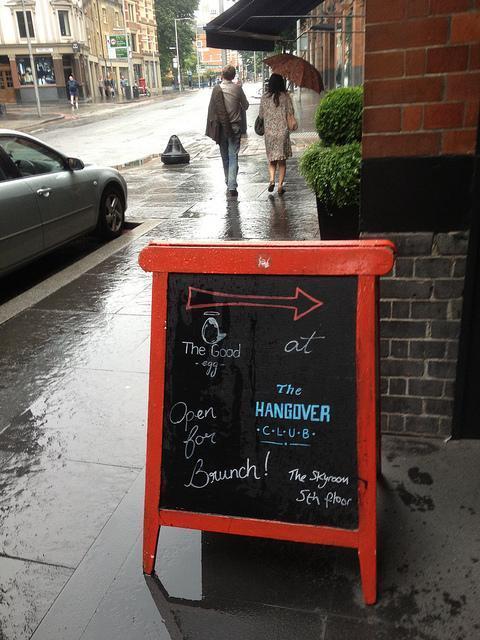How many people are there?
Give a very brief answer. 2. How many bears in this picture?
Give a very brief answer. 0. 